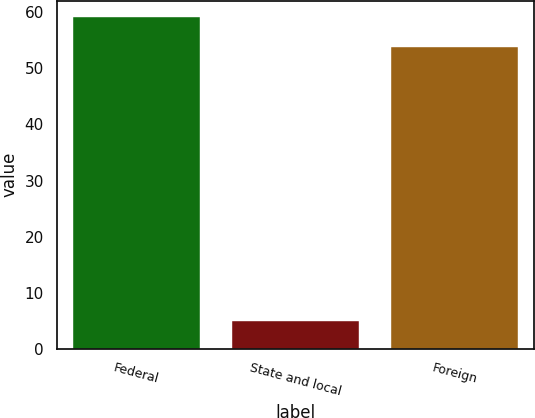<chart> <loc_0><loc_0><loc_500><loc_500><bar_chart><fcel>Federal<fcel>State and local<fcel>Foreign<nl><fcel>59.11<fcel>4.9<fcel>53.9<nl></chart> 